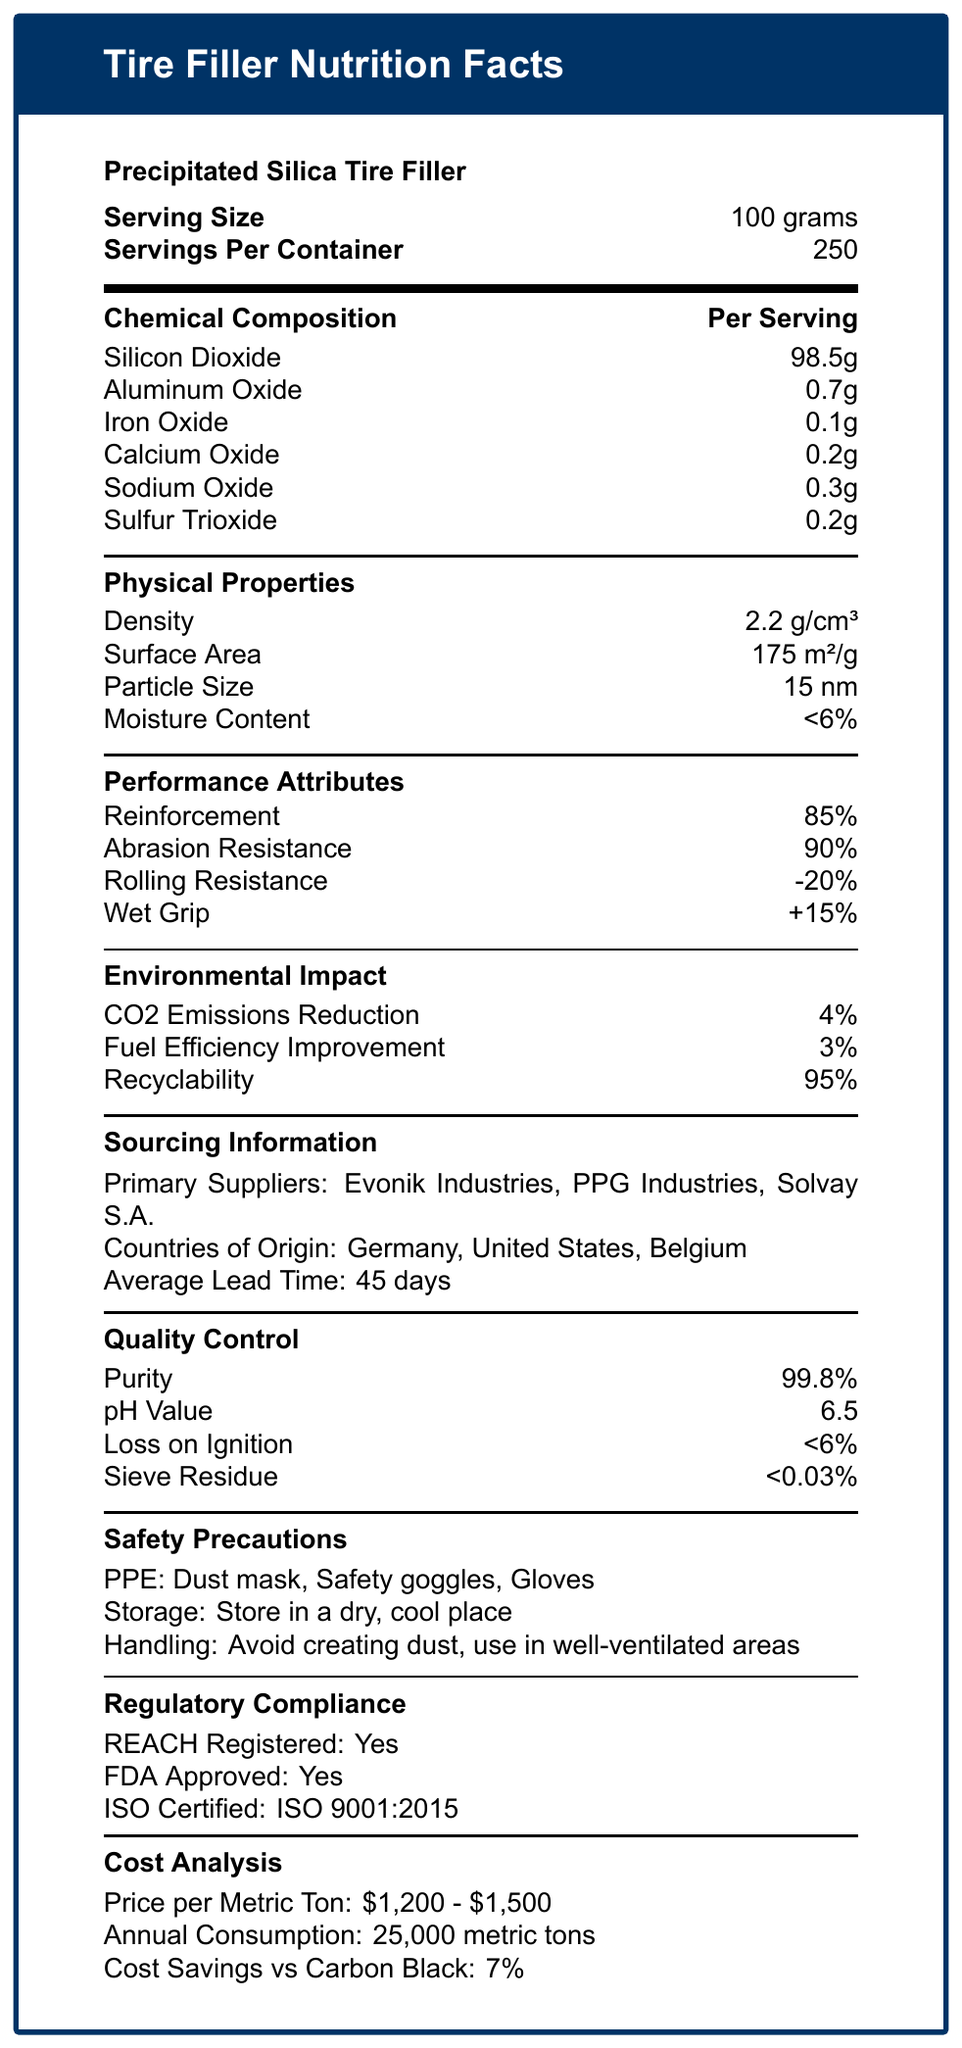what is the serving size of Precipitated Silica Tire Filler? The document states that the serving size is 100 grams.
Answer: 100 grams how many servings are there per container? The document indicates there are 250 servings per container.
Answer: 250 what is the main chemical component of this tire filler? The document lists Silicon Dioxide as the main component at 98.5 grams per serving.
Answer: Silicon dioxide What are the physical properties of the Precipitated Silica Tire Filler? The document lists these four physical properties under the "Physical Properties" section.
Answer: Density, Surface Area, Particle Size, Moisture Content what is the environmental impact in terms of CO2 emissions reduction? The document states that the CO2 emissions reduction is 4%.
Answer: 4% Which of the following is NOT a primary supplier mentioned in the document? A. Dow Chemical B. Evonik Industries C. PPG Industries D. Solvay S.A. The document lists Evonik Industries, PPG Industries, and Solvay S.A. as primary suppliers, but not Dow Chemical.
Answer: A Which country is NOT listed as a country of origin for the Precipitated Silica Tire Filler? 1. Germany 2. United States 3. China 4. Belgium The countries listed in the document are Germany, United States, and Belgium, not China.
Answer: 3 Is the Precipitated Silica Tire Filler FDA approved? The document states under "Regulatory Compliance" that it is FDA approved.
Answer: Yes What are the safety precautions mentioned for handling the Precipitated Silica Tire Filler? The document lists these safety precautions under the "Safety Precautions" section.
Answer: Dust mask, Safety goggles, Gloves, Store in a dry, cool place, Avoid creating dust, use in well-ventilated areas Summarize the main information provided in the document. The document covers various aspects of the tire filler product, including chemical composition, physical properties, performance benefits, sourcing information, quality standards, safety measures, regulatory approvals, and cost analysis, providing a comprehensive overview.
Answer: The document provides detailed information about Precipitated Silica Tire Filler including its serving size, chemical composition, physical properties, performance attributes, environmental impact, sourcing information, quality control, safety precautions, regulatory compliance, and cost analysis. how much fuel efficiency improvement does the Precipitated Silica Tire Filler offer? The document states that the fuel efficiency improvement is 3%.
Answer: 3% what is the average lead time for sourcing this product? The document indicates the average lead time is 45 days.
Answer: 45 days what is the pH value of the product? The document lists the pH value as 6.5.
Answer: 6.5 What is the range of the price per metric ton of Precipitated Silica Tire Filler? The cost analysis section mentions the price per metric ton as $1,200 - $1,500.
Answer: $1,200 - $1,500 What is the annual consumption of Precipitated Silica Tire Filler? The document indicates an annual consumption of 25,000 metric tons.
Answer: 25,000 metric tons Can you identify if the product is suitable for skin contact based on the document? The document does not provide any information regarding the suitability of the product for skin contact.
Answer: Cannot be determined 